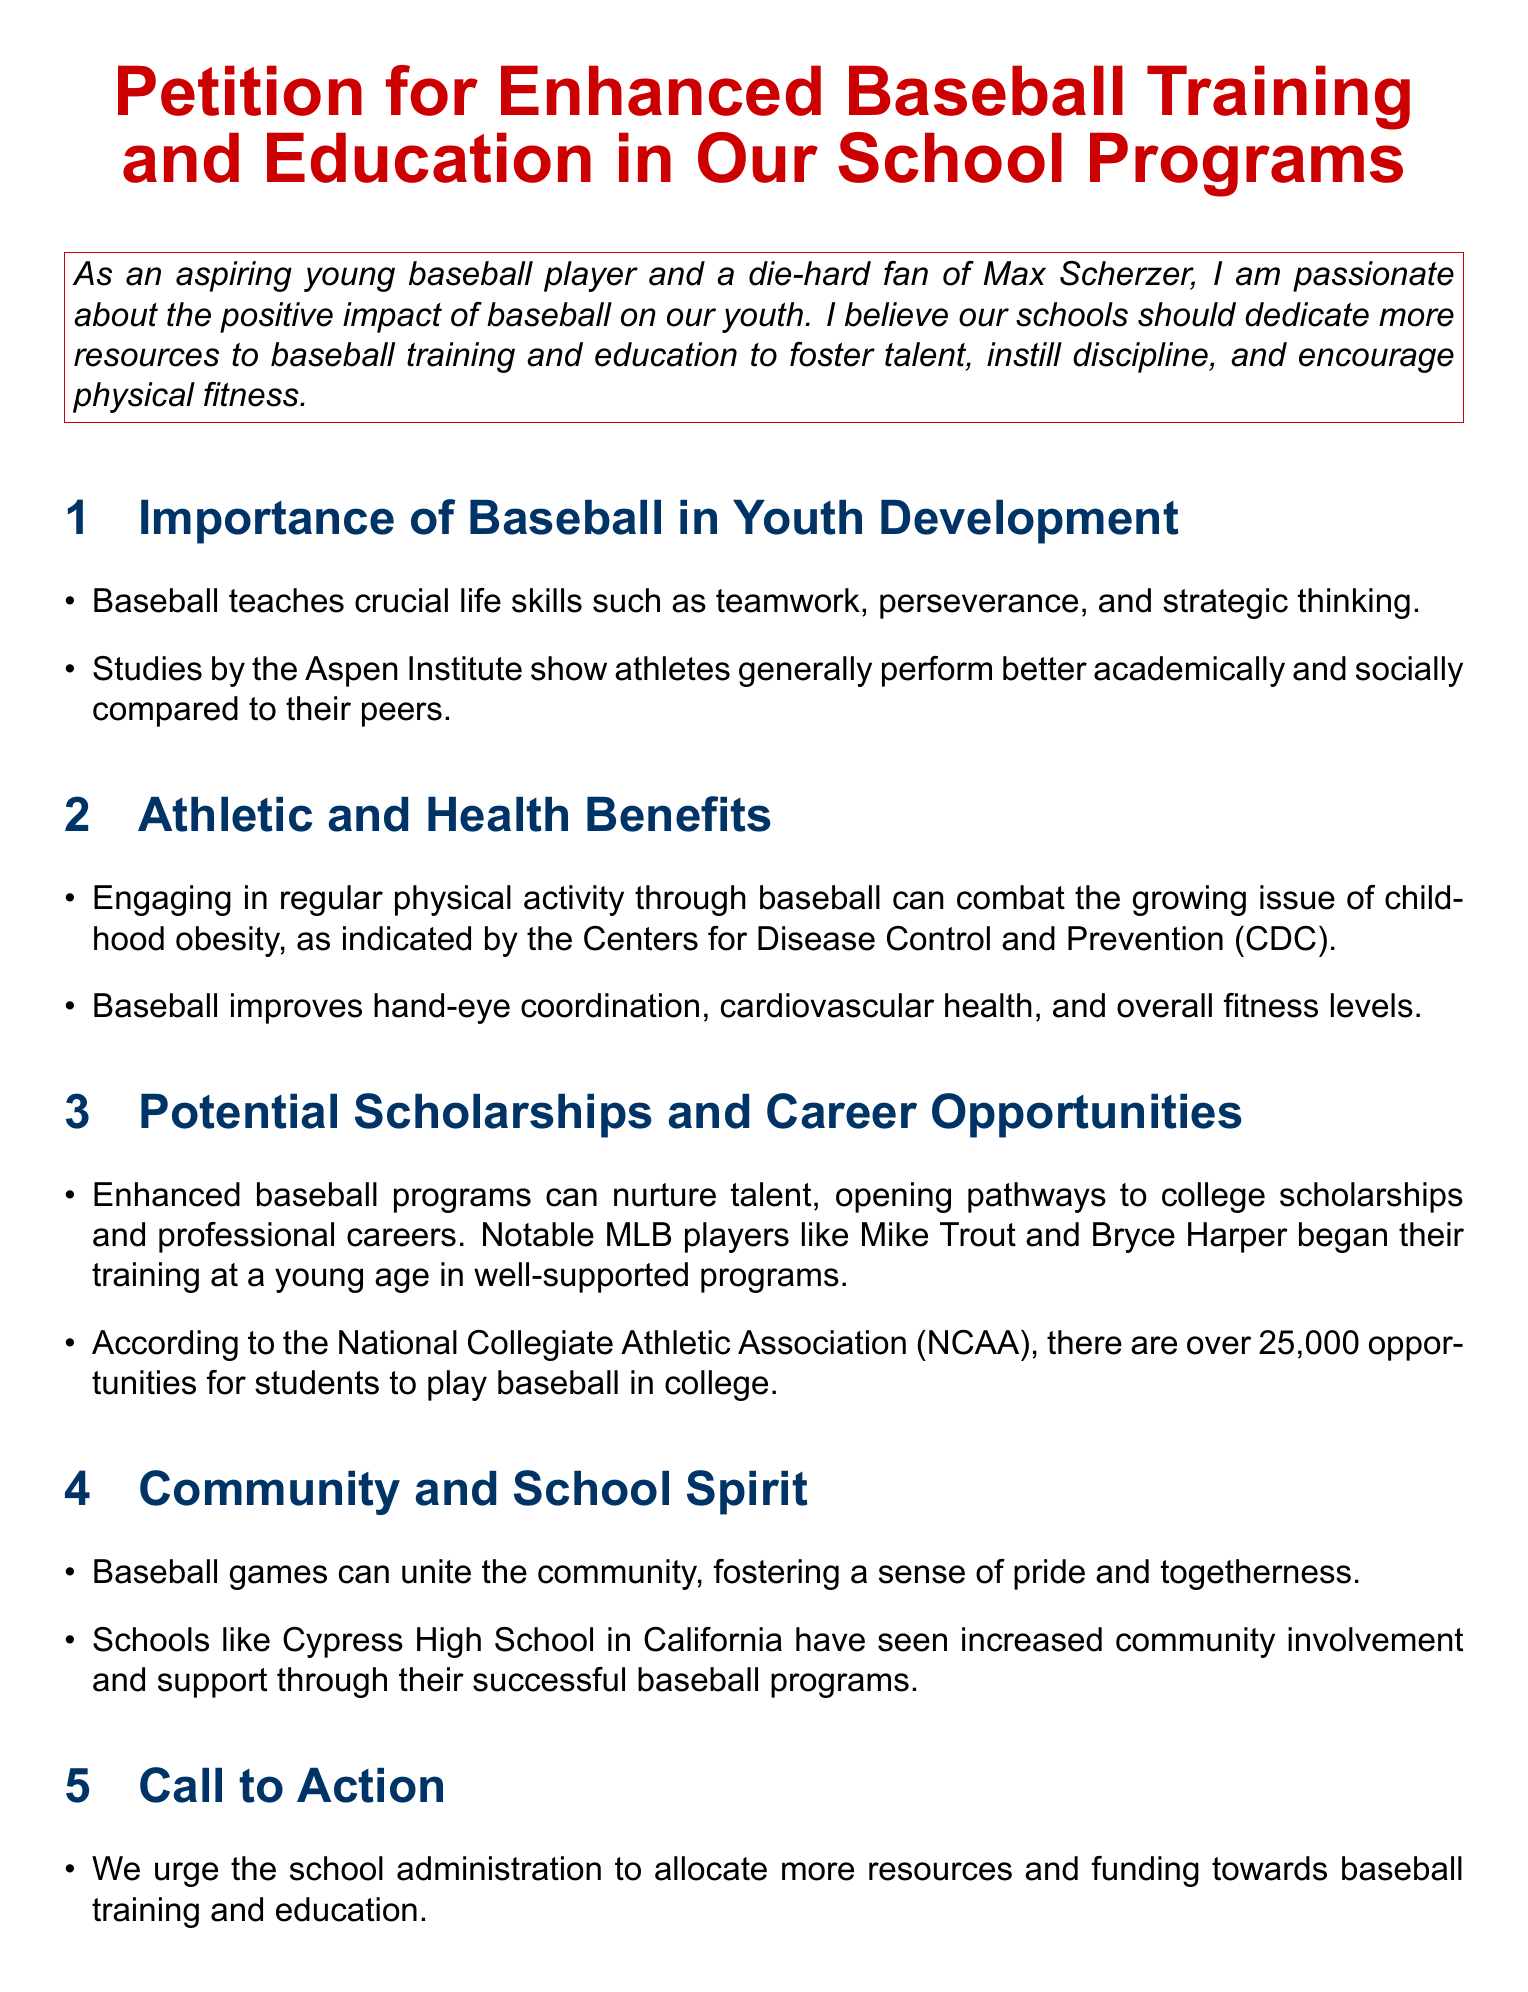What is the title of the petition? The title is stated clearly at the beginning of the document, emphasizing the focus on baseball training and education.
Answer: Petition for Enhanced Baseball Training and Education in Our School Programs What is one life skill that baseball teaches? The document lists crucial life skills that baseball teaches, including teamwork.
Answer: Teamwork According to the Aspen Institute, how do athletes generally perform compared to their peers? The document refers to studies by the Aspen Institute regarding the performance of athletes.
Answer: Better What is one health benefit of engaging in baseball? The athletic benefits section highlights a specific health benefit associated with playing baseball.
Answer: Cardiovascular health How many opportunities does the NCAA provide for students to play baseball in college? The document cites a specific number of opportunities available for students in college baseball according to the NCAA.
Answer: Over 25,000 What can baseball games foster in the community? The document mentions the communal impact of baseball games, focusing on a sense of community and pride.
Answer: Pride What is one proposal made in the call to action? Details from the call to action section show specific proposals for enhancing baseball programs at schools.
Answer: Specialized coaching What is the primary purpose of this petition? The main focus of the document is captured in the conclusion, clarifying the intent behind the advocacy.
Answer: Enhance baseball programs 